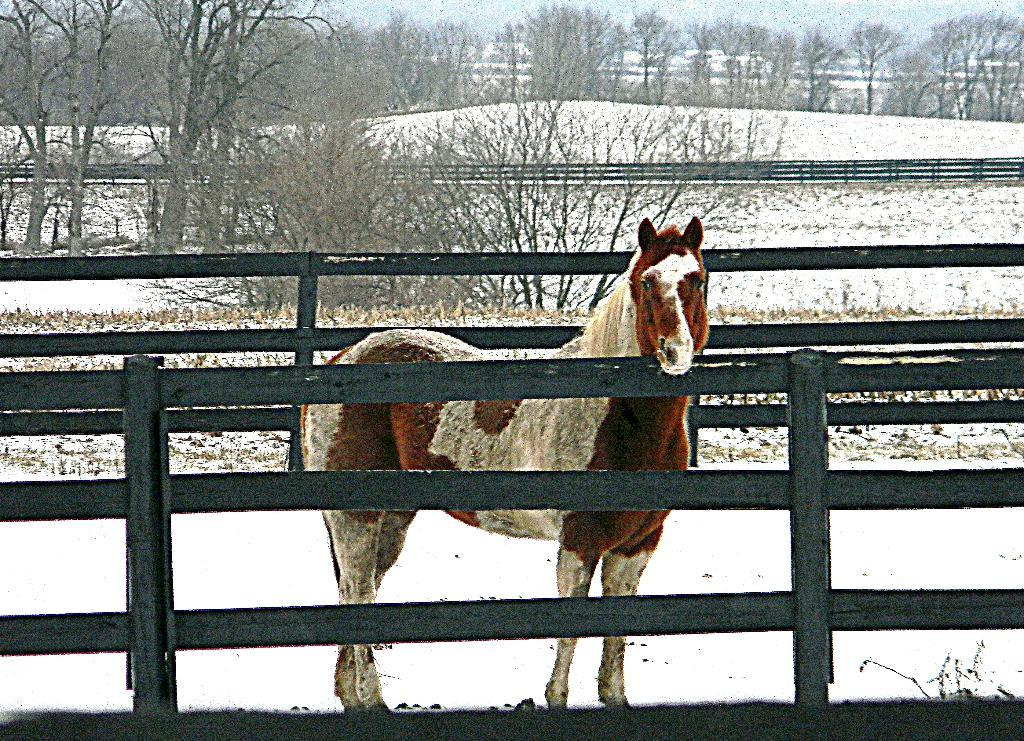What is the main subject in the middle of the image? There is a horse in the middle of the image. What type of structure can be seen in the image? There is a fencing in the image. What is the condition of the land in the image? The land is covered with snow. What can be seen in the background of the image? There are trees in the background of the image. Can you tell me where the kitten is hiding in the image? There is no kitten present in the image. What type of drain is visible in the image? There is no drain present in the image. 